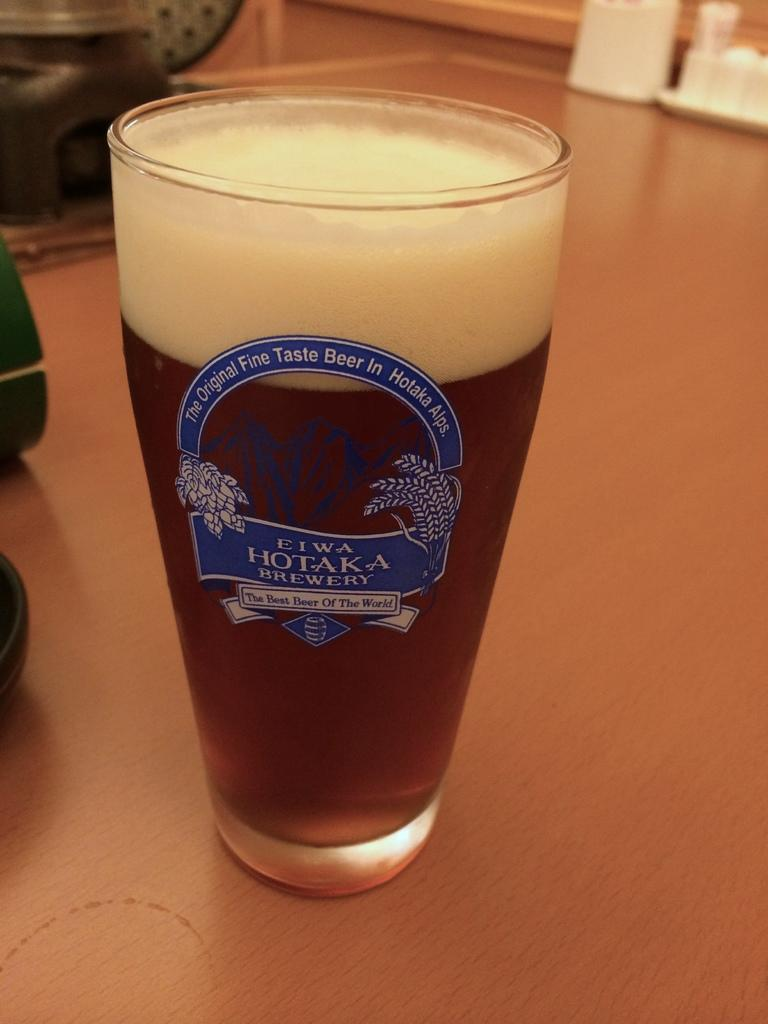What is in the glass that is visible in the image? There is a glass of beer in the image. Where is the glass of beer located? The glass of beer is present on a table. What type of soap is being used to clean the cow in the image? There is no cow or soap present in the image. 